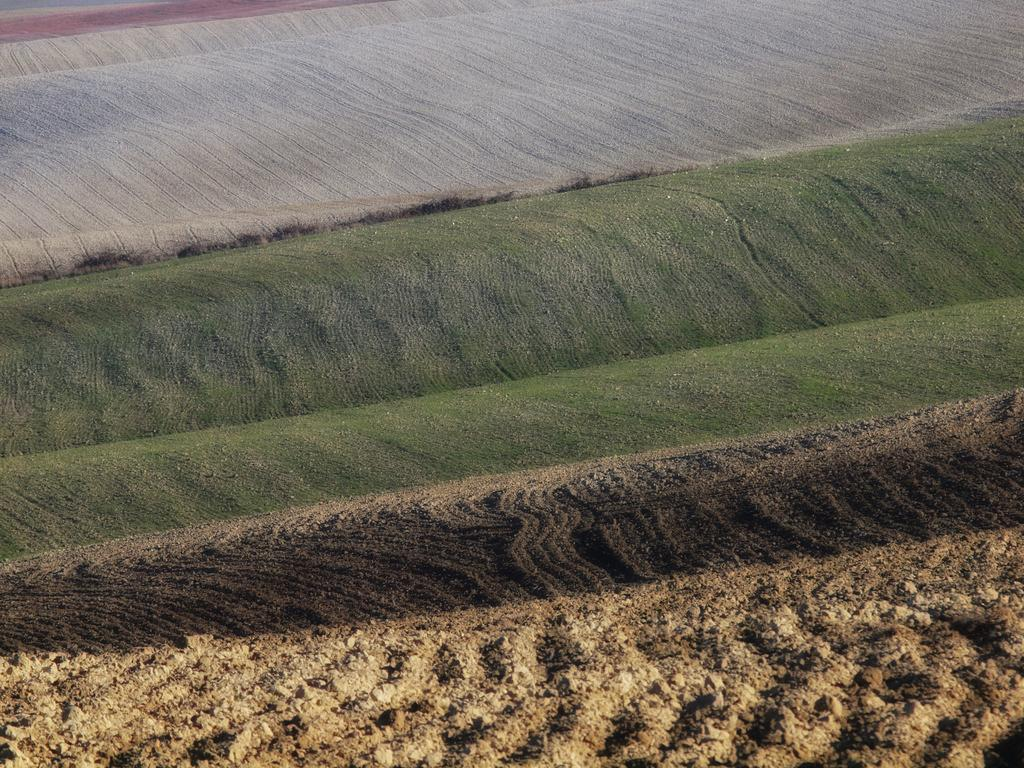What is the main subject of the image? The main subject of the image is a crop. What is the condition of the crop's surface? The crop's surface is muddy. What type of vegetation is visible behind the crop? There is a grass surface and a dried grass surface behind the crop. What type of bread can be seen baking on the stove in the image? There is no stove or bread present in the image; it features a crop with a muddy surface and vegetation behind it. 